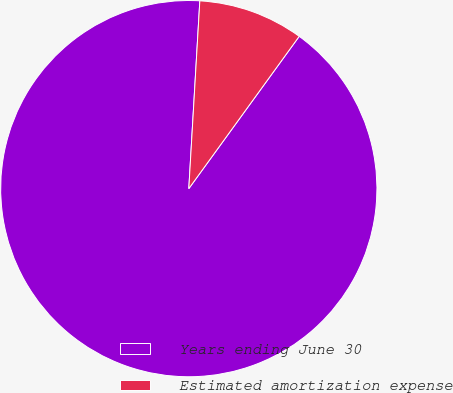Convert chart to OTSL. <chart><loc_0><loc_0><loc_500><loc_500><pie_chart><fcel>Years ending June 30<fcel>Estimated amortization expense<nl><fcel>90.95%<fcel>9.05%<nl></chart> 